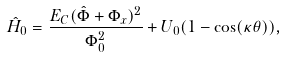<formula> <loc_0><loc_0><loc_500><loc_500>\hat { H } _ { 0 } = \frac { E _ { C } ( \hat { \Phi } + \Phi _ { x } ) ^ { 2 } } { \Phi _ { 0 } ^ { 2 } } + U _ { 0 } ( 1 - \cos ( \kappa \theta ) ) ,</formula> 